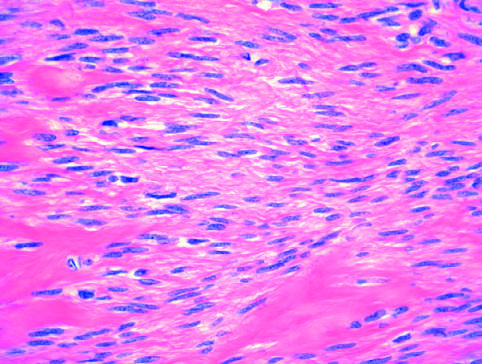what shows bundles of normal-looking smooth muscle cells?
Answer the question using a single word or phrase. Microscopic appearance of leiomyoma 